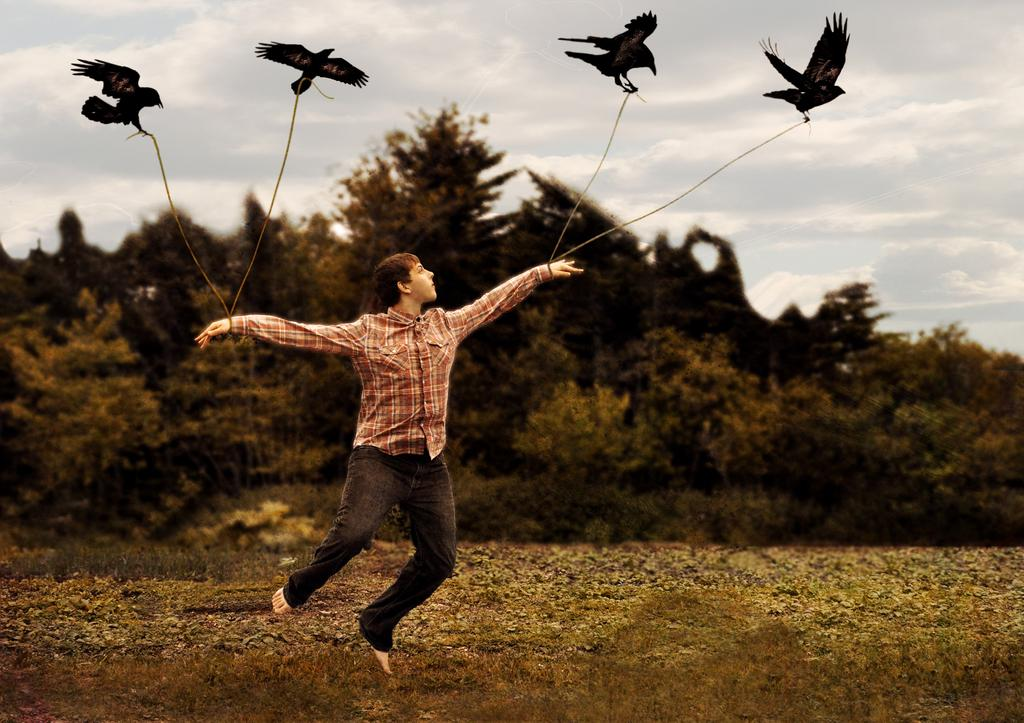Who or what is present in the image? There is a person in the image. What other living creatures can be seen in the image? There are birds in the image. What is the condition of the sky in the image? The sky contains clouds in the image. What type of vegetation is visible in the image? There are many trees and plants in the image. What month is it in the image? The month cannot be determined from the image, as there is no information about the date or time of year. Can you see a zebra in the image? No, there is no zebra present in the image. 